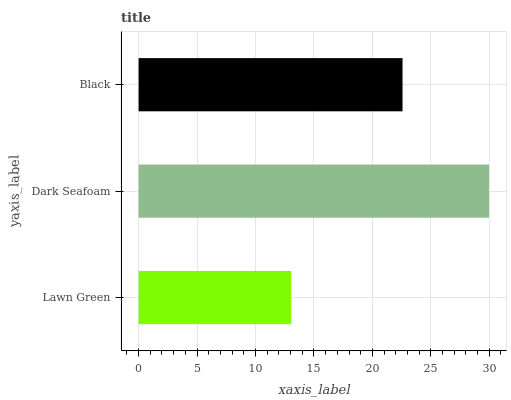Is Lawn Green the minimum?
Answer yes or no. Yes. Is Dark Seafoam the maximum?
Answer yes or no. Yes. Is Black the minimum?
Answer yes or no. No. Is Black the maximum?
Answer yes or no. No. Is Dark Seafoam greater than Black?
Answer yes or no. Yes. Is Black less than Dark Seafoam?
Answer yes or no. Yes. Is Black greater than Dark Seafoam?
Answer yes or no. No. Is Dark Seafoam less than Black?
Answer yes or no. No. Is Black the high median?
Answer yes or no. Yes. Is Black the low median?
Answer yes or no. Yes. Is Lawn Green the high median?
Answer yes or no. No. Is Dark Seafoam the low median?
Answer yes or no. No. 